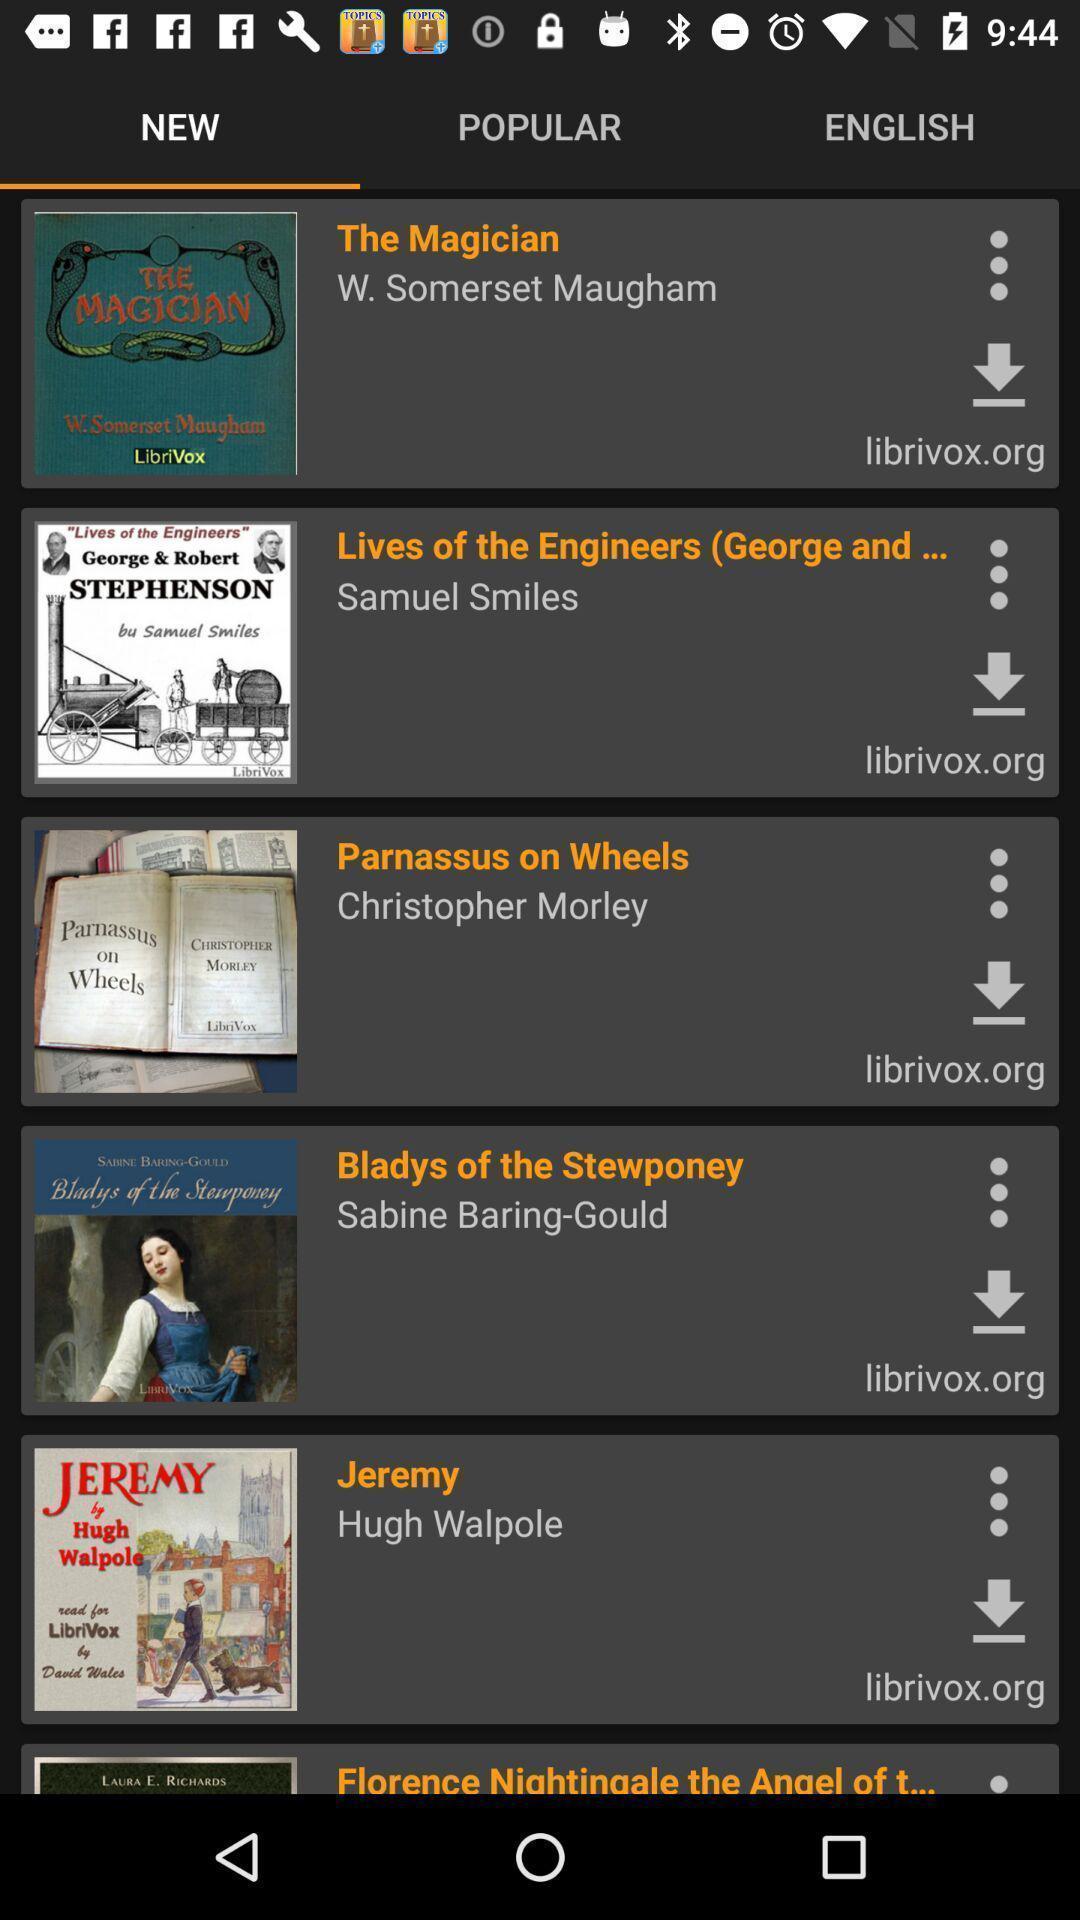Provide a detailed account of this screenshot. Page showing the thumbnails in new tab. 